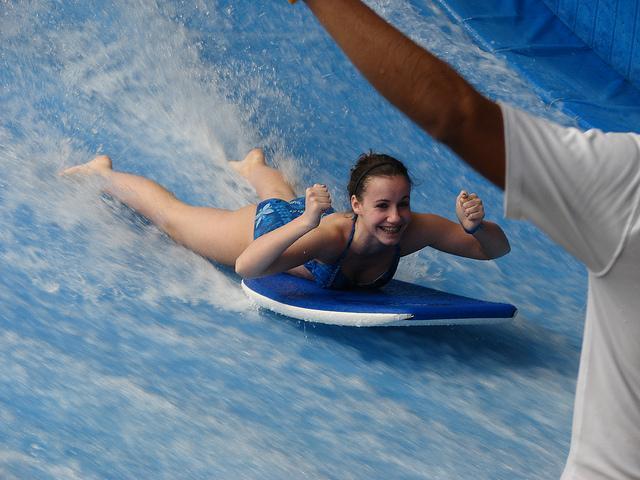How many people are in the photo?
Give a very brief answer. 2. How many skis are shown?
Give a very brief answer. 0. 